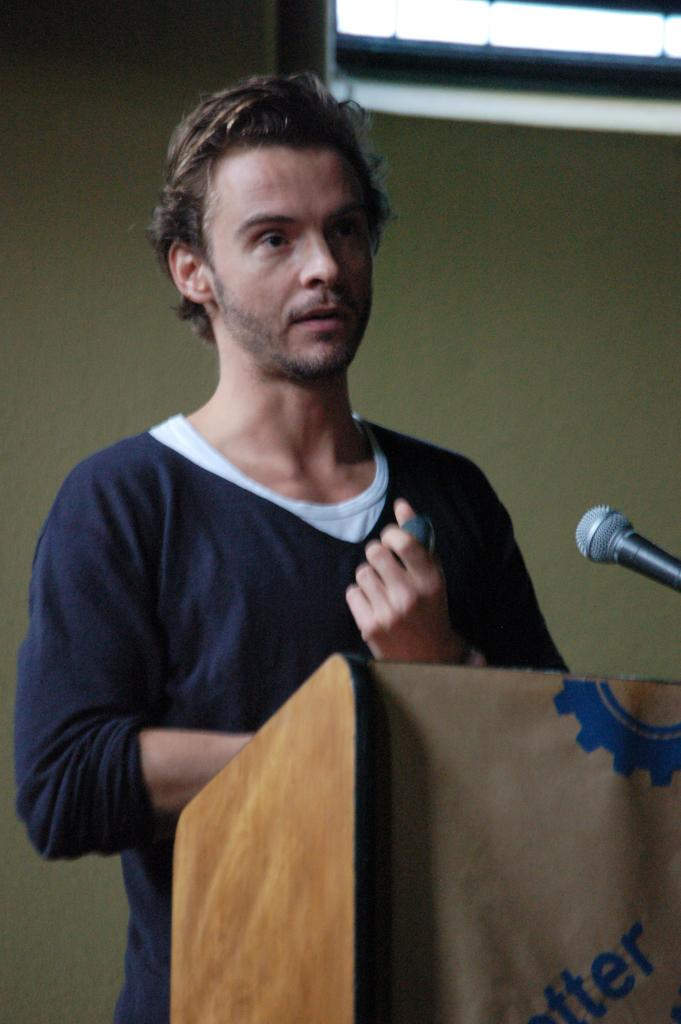What is the man in the image doing? The man is standing behind a podium in the image. What object is on the podium? There is a microphone on the podium. What can be seen on the wall in the background of the image? There is a screen visible in the image. What is the man likely to use the microphone for? The man might use the microphone to amplify his voice during a presentation or speech. What type of bead is being used to create the bubbles in the image? There are no beads or bubbles present in the image. What class is the man teaching in the image? The image does not provide any information about the man teaching a class. 